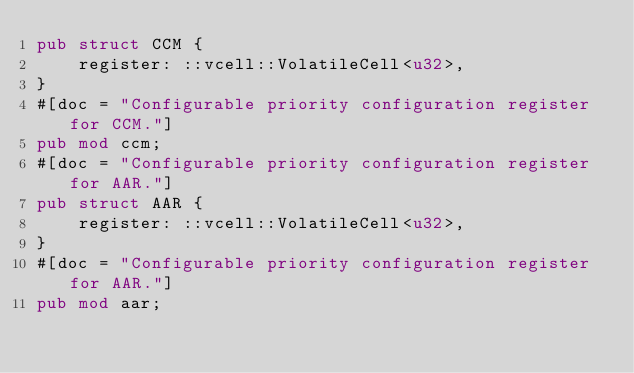<code> <loc_0><loc_0><loc_500><loc_500><_Rust_>pub struct CCM {
    register: ::vcell::VolatileCell<u32>,
}
#[doc = "Configurable priority configuration register for CCM."]
pub mod ccm;
#[doc = "Configurable priority configuration register for AAR."]
pub struct AAR {
    register: ::vcell::VolatileCell<u32>,
}
#[doc = "Configurable priority configuration register for AAR."]
pub mod aar;
</code> 